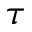<formula> <loc_0><loc_0><loc_500><loc_500>\tau</formula> 